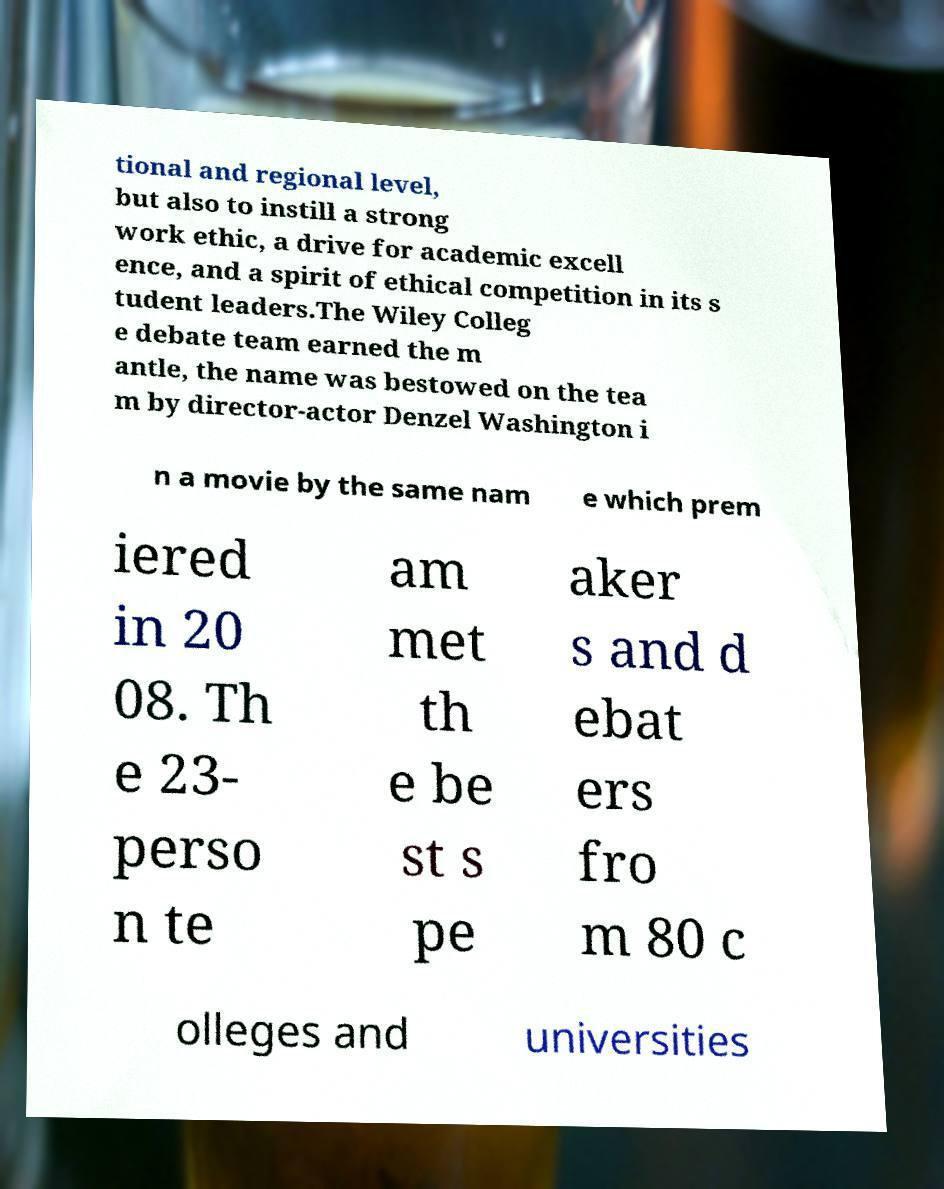There's text embedded in this image that I need extracted. Can you transcribe it verbatim? tional and regional level, but also to instill a strong work ethic, a drive for academic excell ence, and a spirit of ethical competition in its s tudent leaders.The Wiley Colleg e debate team earned the m antle, the name was bestowed on the tea m by director-actor Denzel Washington i n a movie by the same nam e which prem iered in 20 08. Th e 23- perso n te am met th e be st s pe aker s and d ebat ers fro m 80 c olleges and universities 